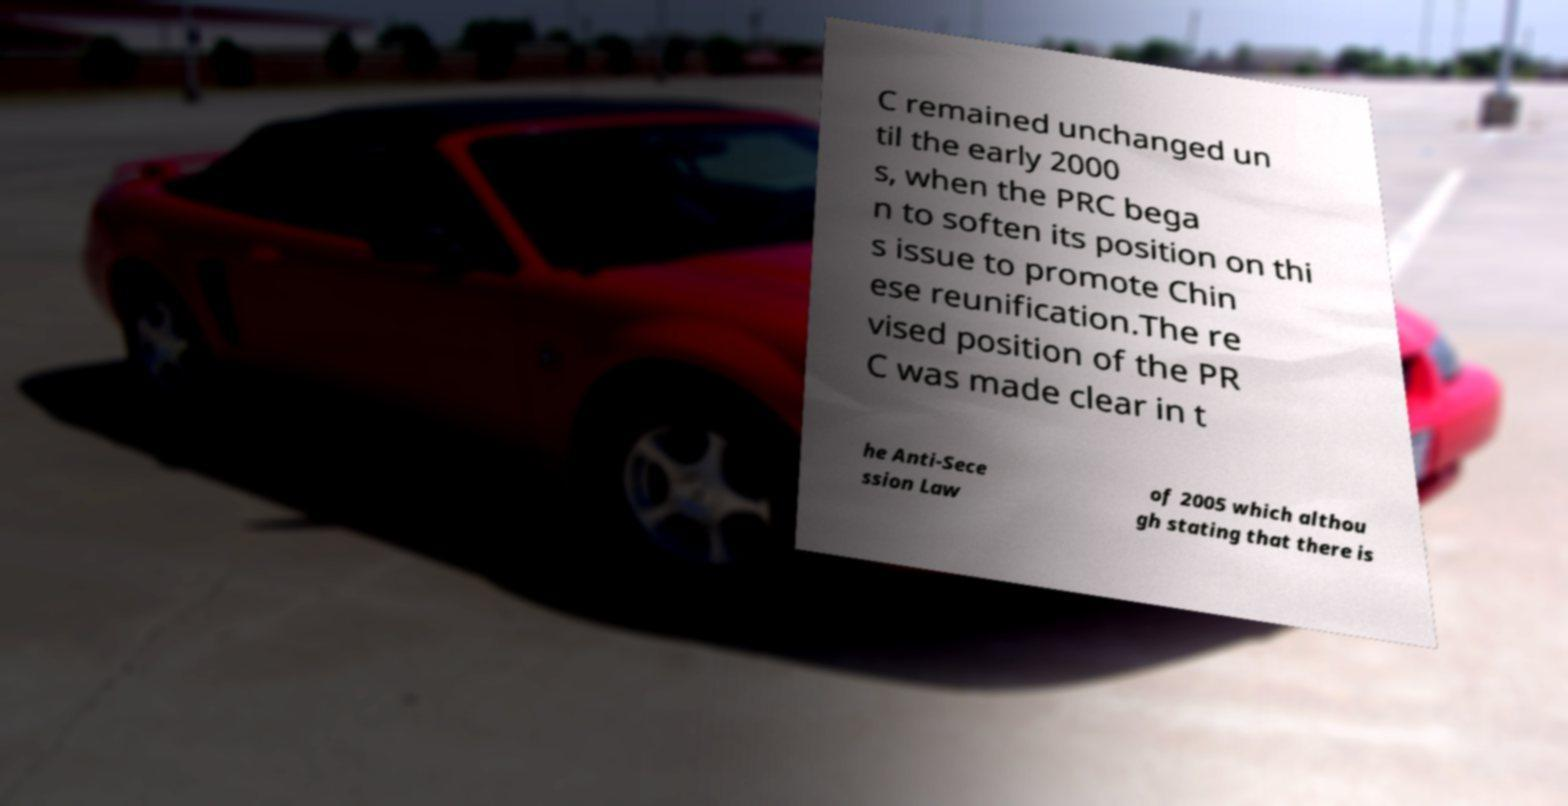There's text embedded in this image that I need extracted. Can you transcribe it verbatim? C remained unchanged un til the early 2000 s, when the PRC bega n to soften its position on thi s issue to promote Chin ese reunification.The re vised position of the PR C was made clear in t he Anti-Sece ssion Law of 2005 which althou gh stating that there is 